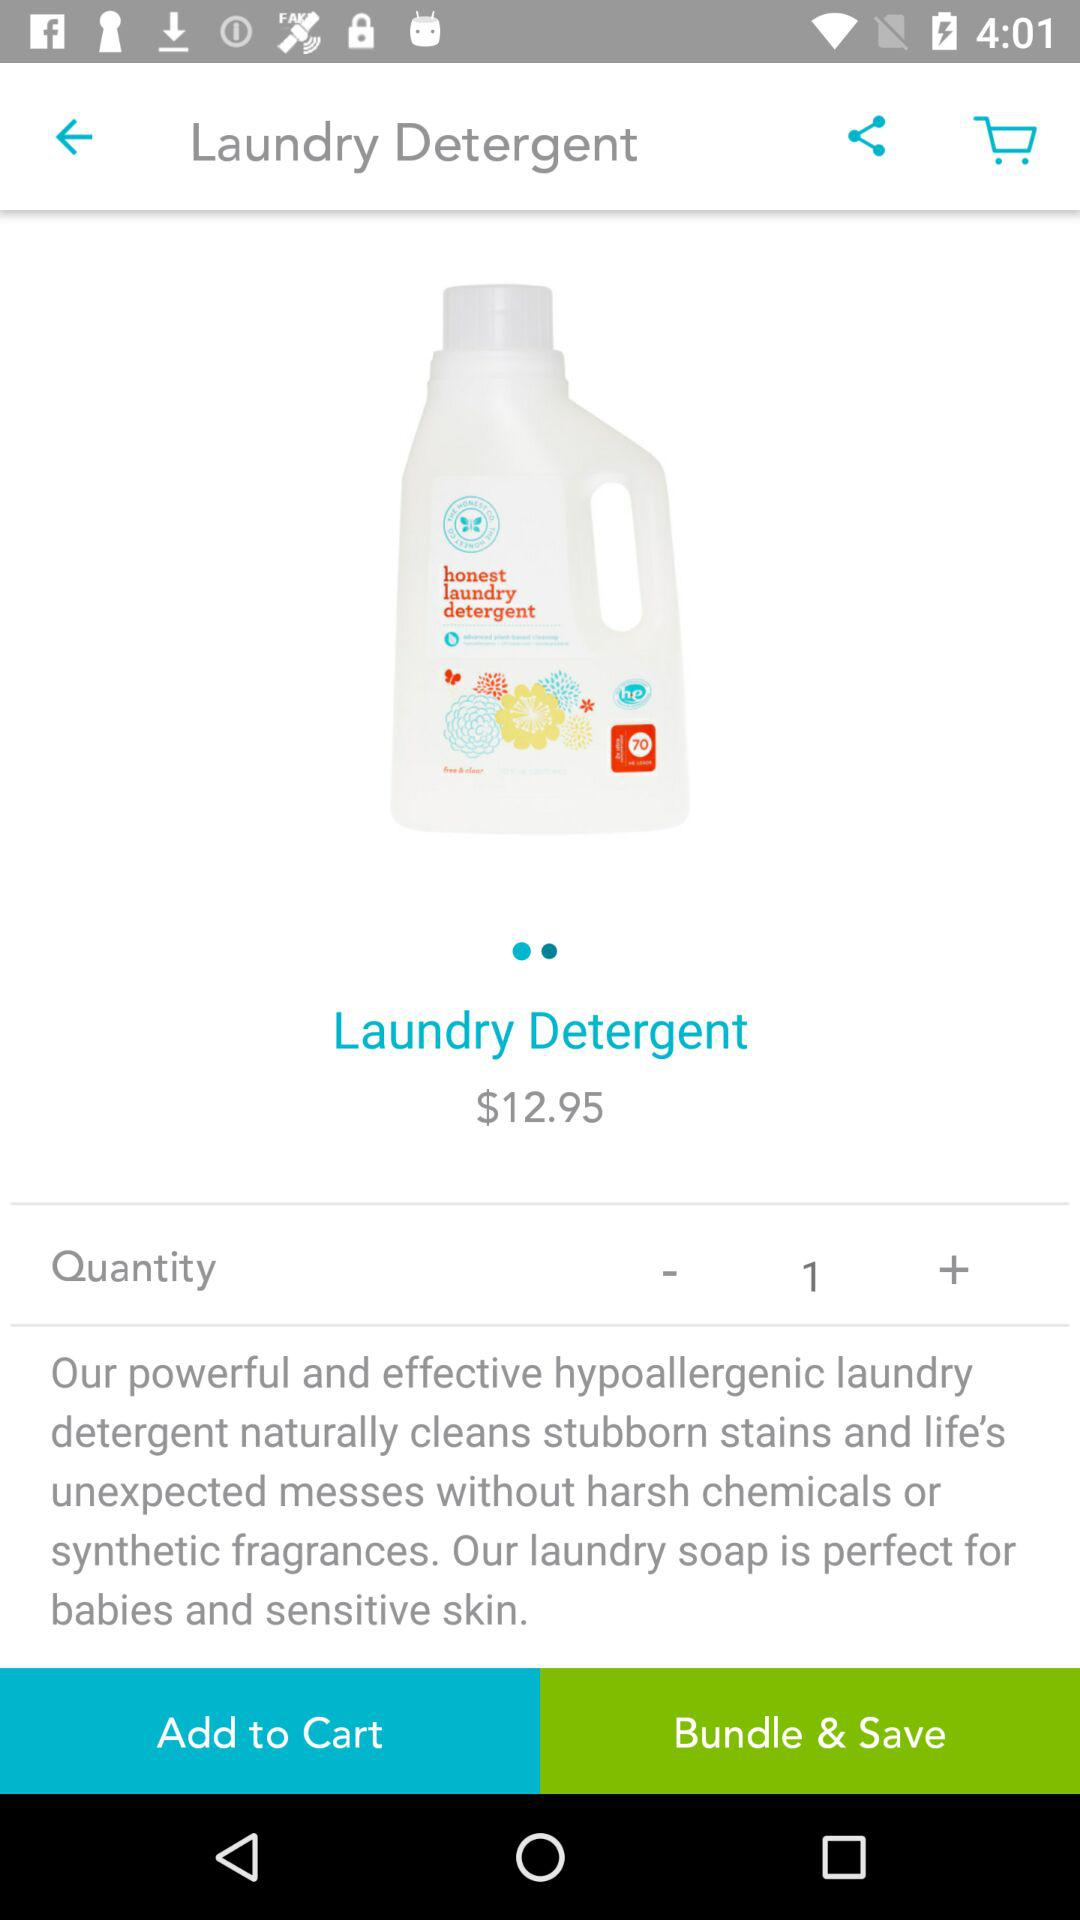How many units of the product are currently in the cart?
Answer the question using a single word or phrase. 1 